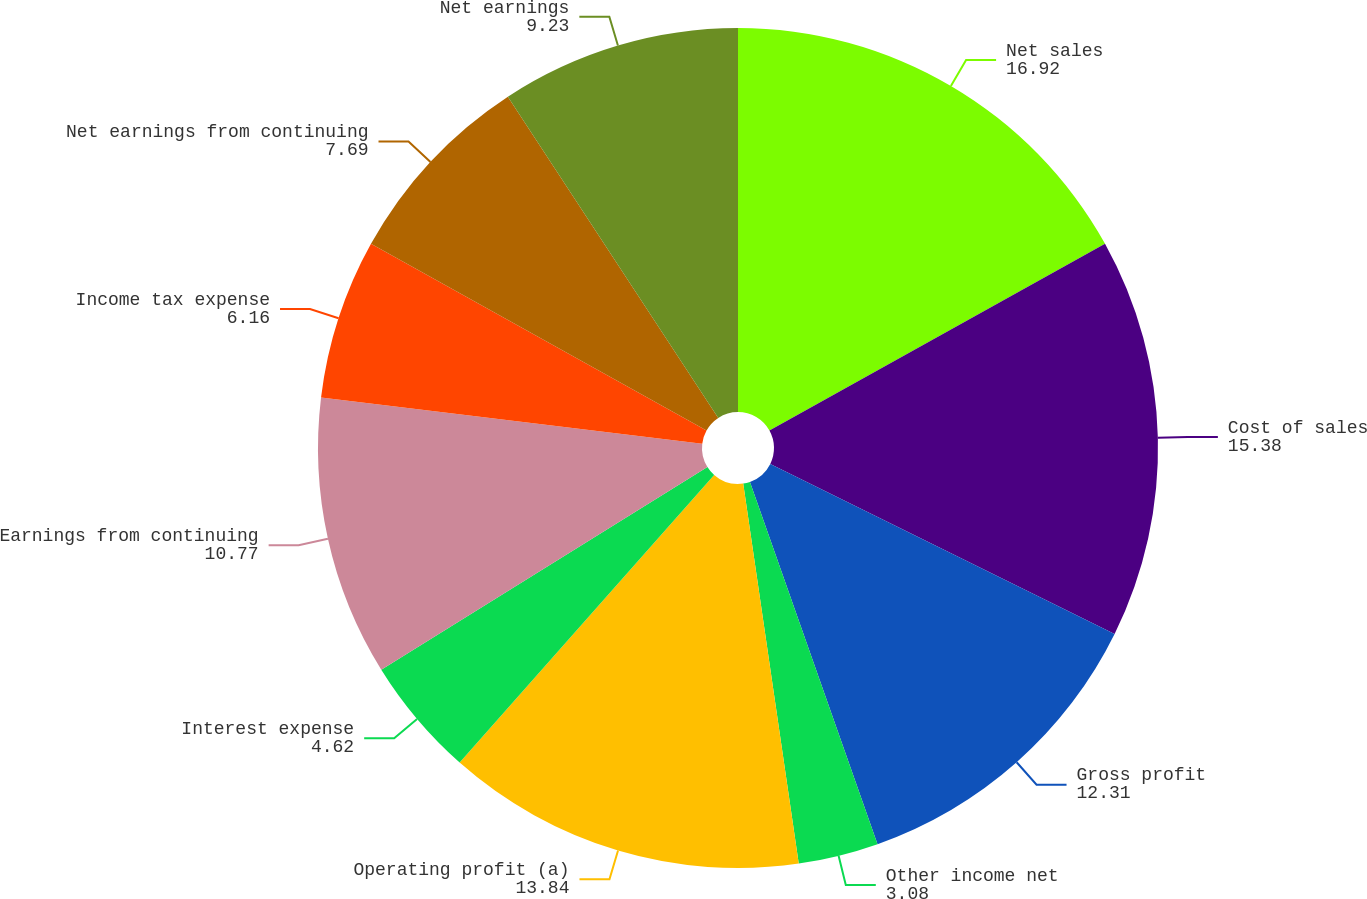Convert chart to OTSL. <chart><loc_0><loc_0><loc_500><loc_500><pie_chart><fcel>Net sales<fcel>Cost of sales<fcel>Gross profit<fcel>Other income net<fcel>Operating profit (a)<fcel>Interest expense<fcel>Earnings from continuing<fcel>Income tax expense<fcel>Net earnings from continuing<fcel>Net earnings<nl><fcel>16.92%<fcel>15.38%<fcel>12.31%<fcel>3.08%<fcel>13.84%<fcel>4.62%<fcel>10.77%<fcel>6.16%<fcel>7.69%<fcel>9.23%<nl></chart> 